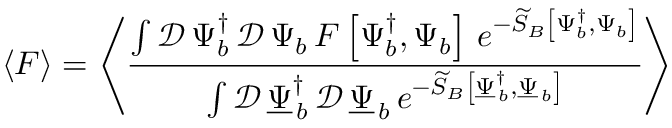<formula> <loc_0><loc_0><loc_500><loc_500>\left \langle F \right \rangle = \left \langle \frac { \int \mathcal { D } \, \Psi _ { b } ^ { \dagger } \, \mathcal { D } \, \Psi _ { b } \, F \left [ \Psi _ { b } ^ { \dagger } , \Psi _ { b } \right ] \, e ^ { - \widetilde { S } _ { B } \left [ \Psi _ { b } ^ { \dagger } , \Psi _ { b } \right ] } } { \int \mathcal { D } \, \underline { \Psi } _ { \, b } ^ { \dagger } \, \mathcal { D } \, \underline { \Psi } _ { \, b } \, e ^ { - \widetilde { S } _ { B } \left [ \underline { \Psi } _ { \, b } ^ { \dagger } , \underline { \Psi } _ { \, b } \right ] } } \right \rangle</formula> 